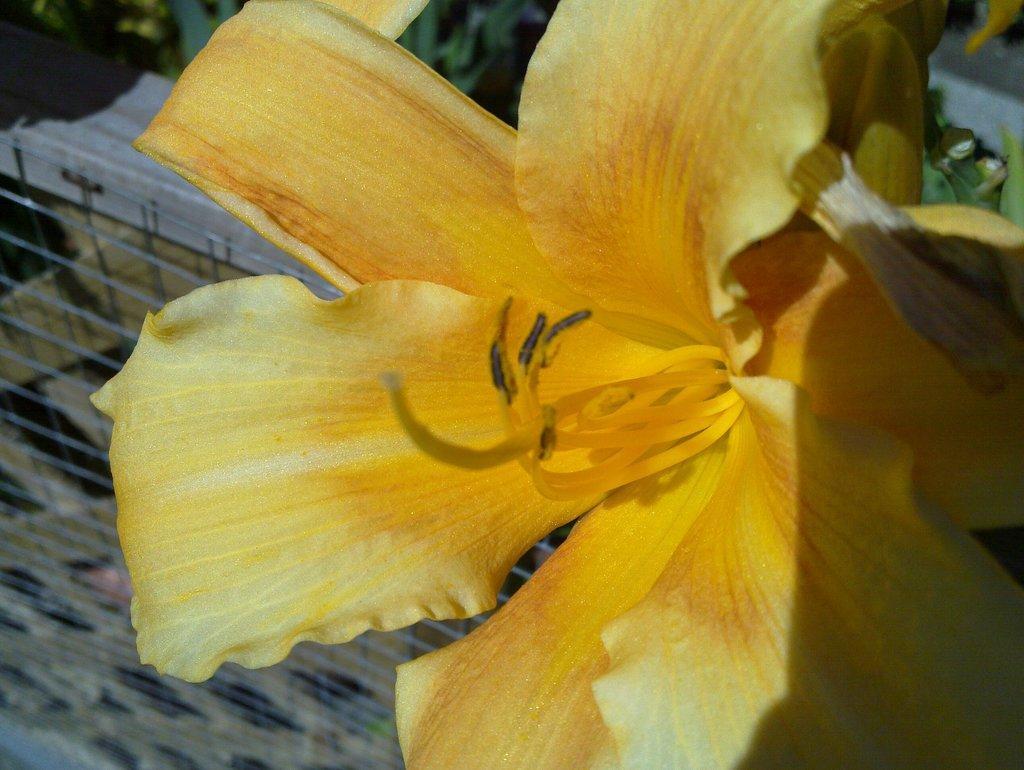In one or two sentences, can you explain what this image depicts? In this picture in the front there are flowers and in the background there are plants and there is net which is visible in the background. 